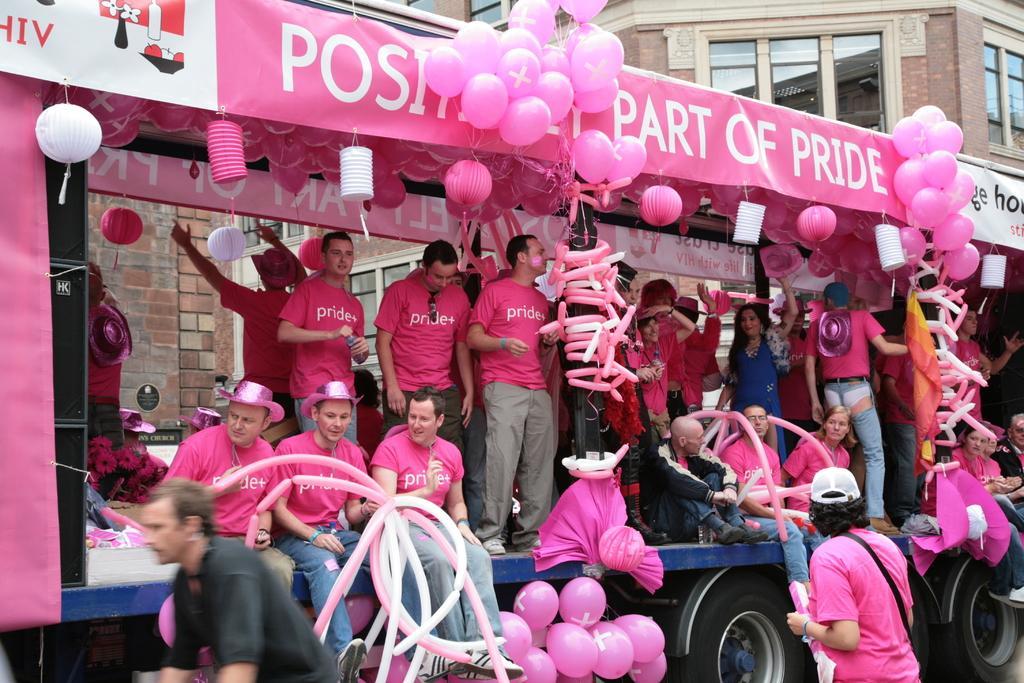Describe this image in one or two sentences. In this picture there are people and we can see a vehicle, balloons, banners and decorative objects. In the background of the image we can see building, windows and wall. 